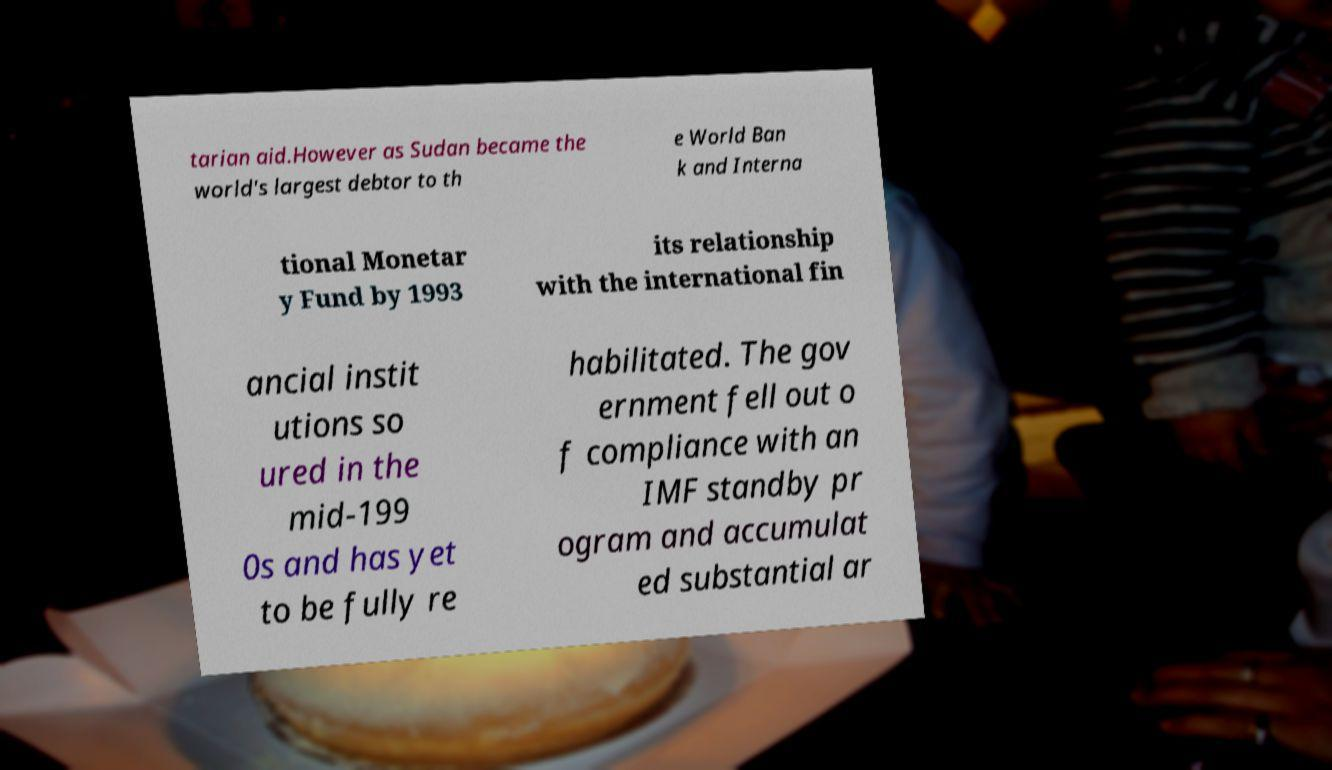For documentation purposes, I need the text within this image transcribed. Could you provide that? tarian aid.However as Sudan became the world's largest debtor to th e World Ban k and Interna tional Monetar y Fund by 1993 its relationship with the international fin ancial instit utions so ured in the mid-199 0s and has yet to be fully re habilitated. The gov ernment fell out o f compliance with an IMF standby pr ogram and accumulat ed substantial ar 